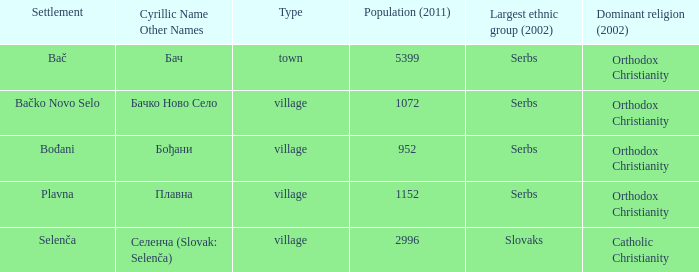What is the ethnic majority in the only town? Serbs. 